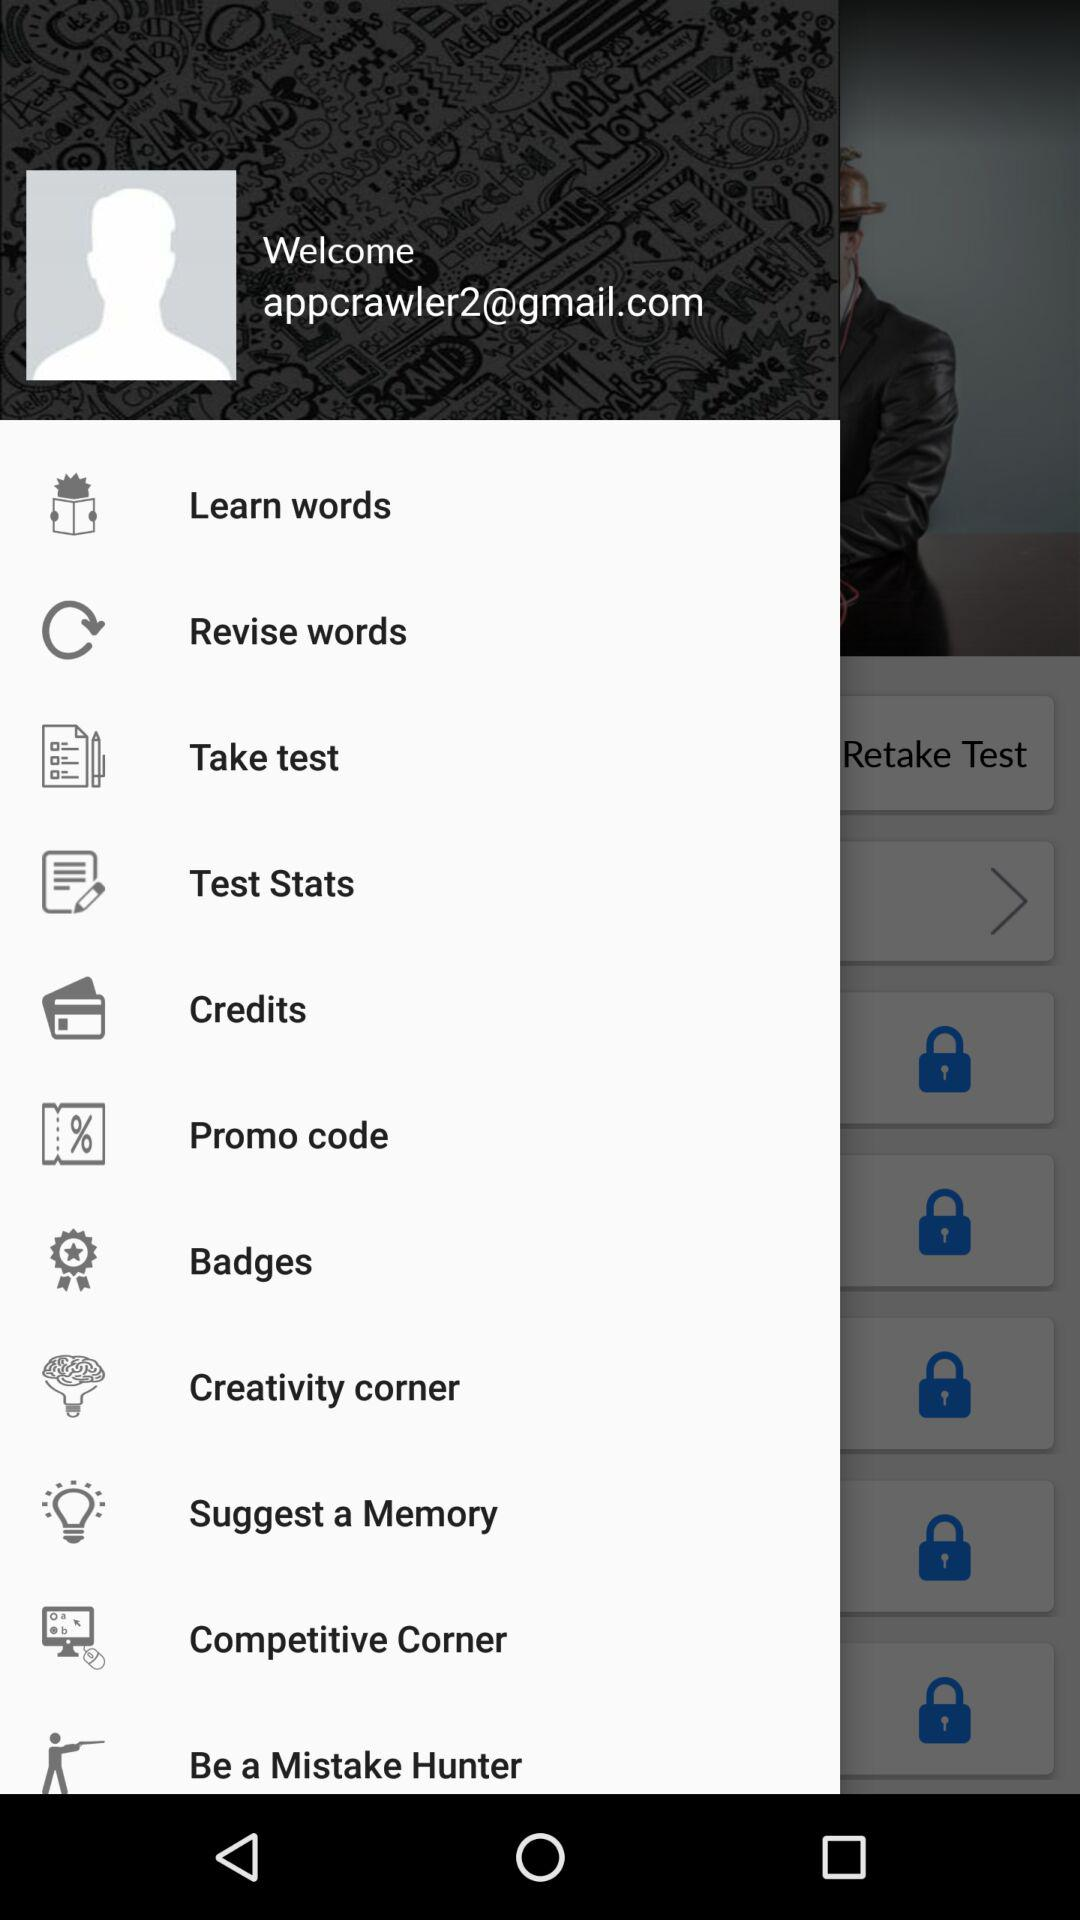Which option was selected?
When the provided information is insufficient, respond with <no answer>. <no answer> 